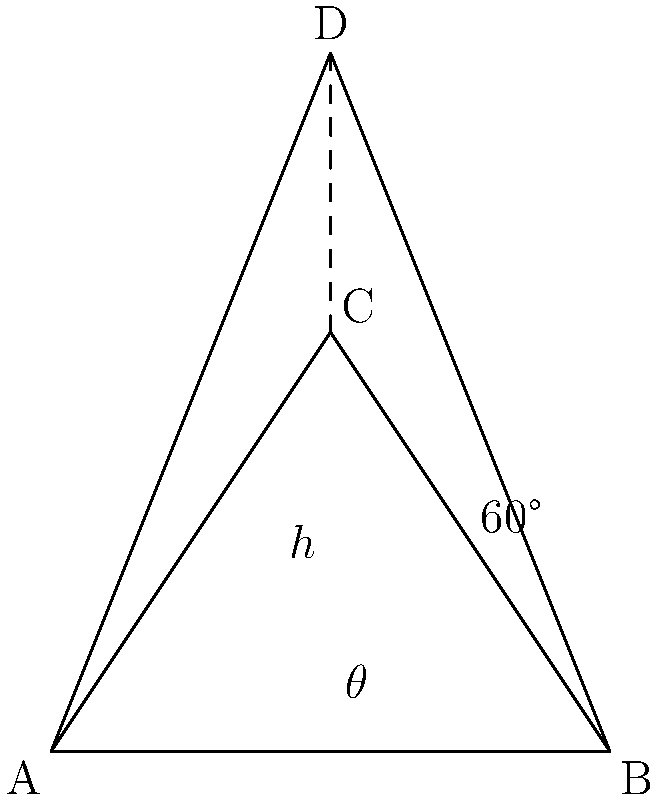In the ancient Egyptian pyramidal structure shown above, the base ABC forms an equilateral triangle with side length 4 units. Point D represents the apex of the pyramid. Given that the angle between the base and a face of the pyramid (angle BAD) is 60°, calculate the height (h) of the pyramid. How might this structure reflect the patriarchal power dynamics in ancient Egyptian society? Let's approach this step-by-step:

1) In the equilateral triangle ABC:
   - The height of the triangle (CH) = $\frac{\sqrt{3}}{2} \times 4 = 2\sqrt{3}$ units

2) In the right triangle ADH:
   - $\tan 60° = \frac{h}{2}$ (where h is the height of the pyramid)
   - We know that $\tan 60° = \sqrt{3}$

3) Therefore:
   $\sqrt{3} = \frac{h}{2}$
   $h = 2\sqrt{3}$ units

4) Interestingly, this means that the height of the pyramid is equal to the height of the base triangle.

5) To calculate the exact value:
   $h = 2\sqrt{3} \approx 3.464$ units

From a historical perspective, this pyramidal structure could be seen as a reflection of the patriarchal power dynamics in ancient Egyptian society. The pyramid's shape, with a wide base narrowing to a single point at the apex, might symbolize the social hierarchy:

- The broad base could represent the majority of the population.
- The narrowing sides could represent the decreasing numbers in each higher social class.
- The singular apex could represent the pharaoh, typically male, at the top of the social and political structure.

The precise mathematical calculations required to construct such a structure also demonstrate the advanced knowledge held by the ruling class, potentially used to maintain their power and reinforce their claimed divine right to rule.
Answer: $2\sqrt{3}$ units or approximately 3.464 units 